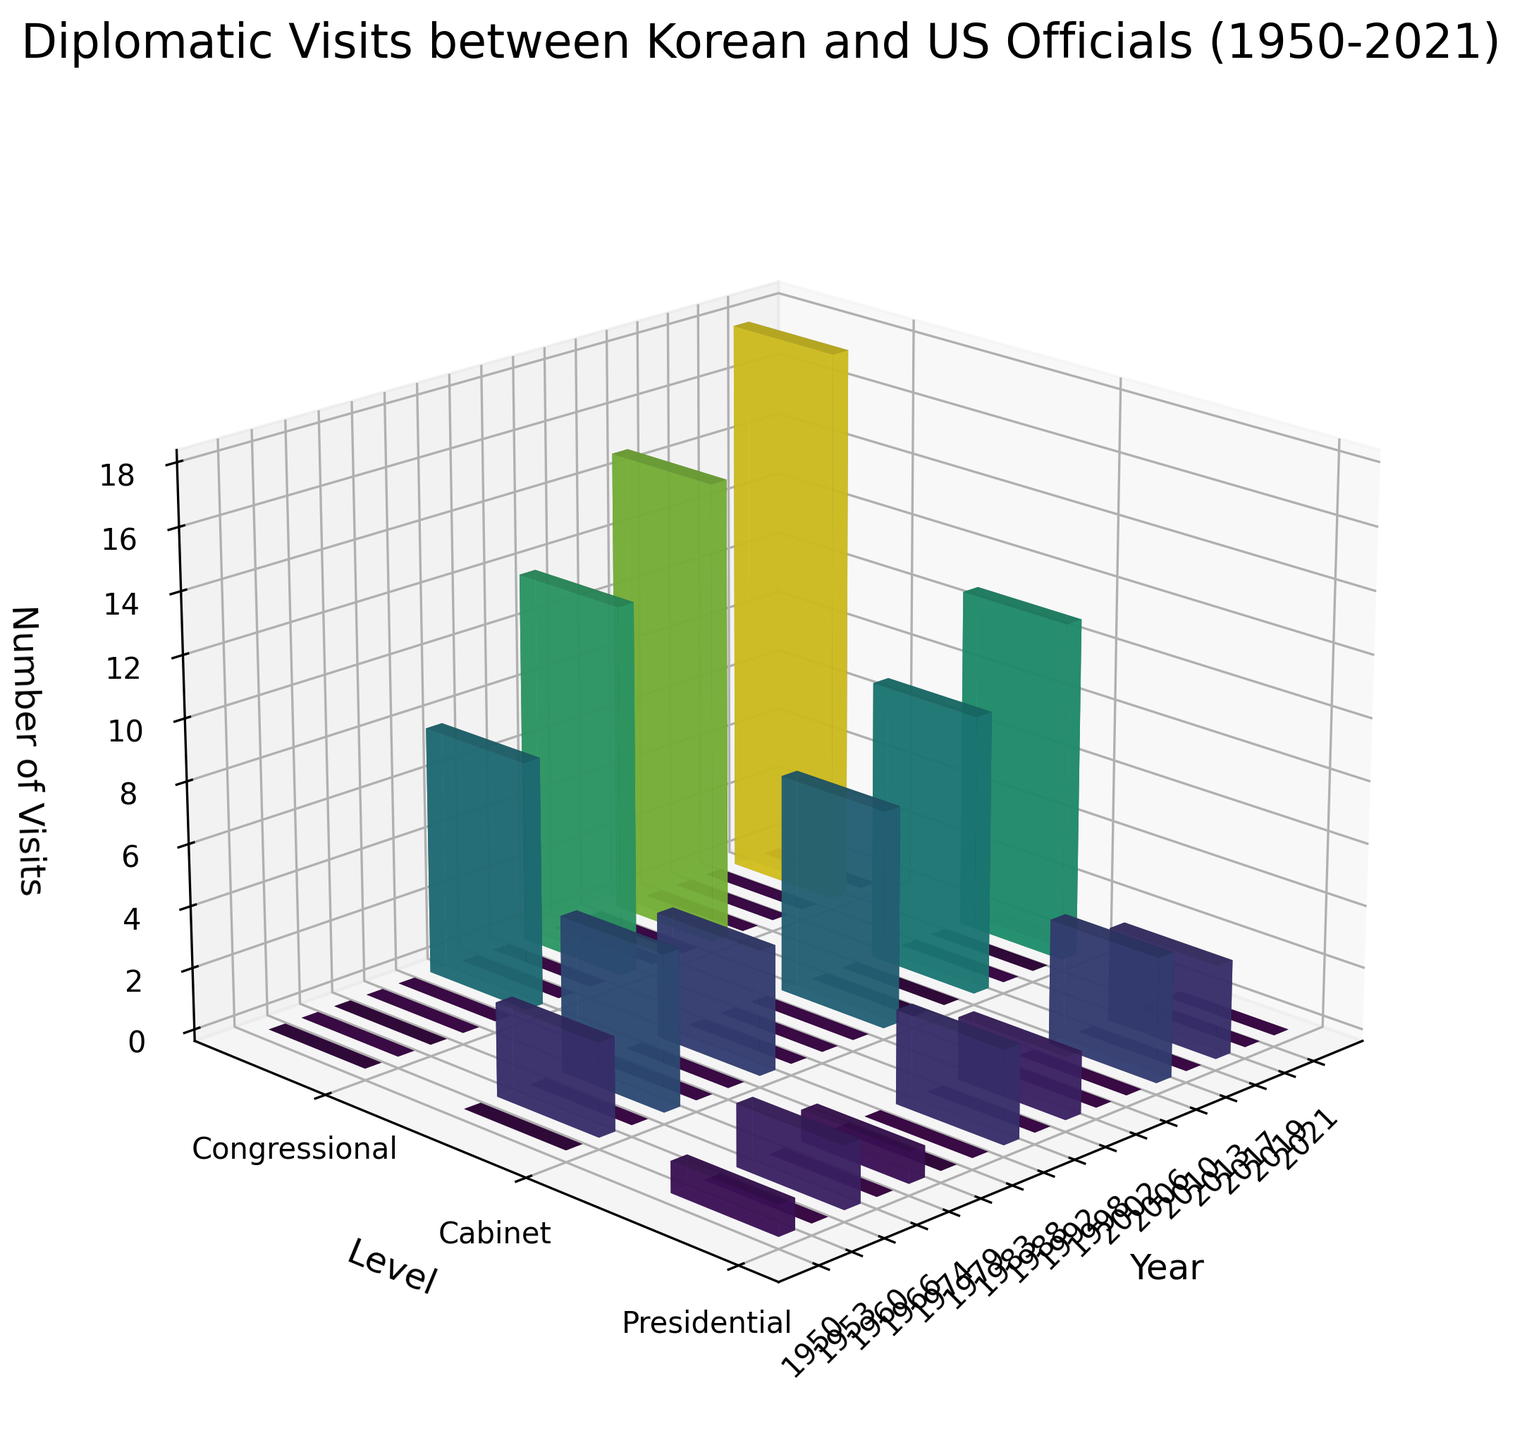What is the title of the plot? The title is the text located at the top of the plot which describes the overall content.
Answer: Diplomatic Visits between Korean and US Officials (1950-2021) What are the levels of government represented in the plot? The levels can be identified by looking at the y-axis labels in the plot.
Answer: Presidential, Cabinet, Congressional Which level of government had the highest number of visits in any given year? This requires scanning the bars in the plot to find the tallest one, then identifying its corresponding level. The highest bar is found in the Congressional level.
Answer: Congressional In which year did the Congressional level have the most visits? Observe the Congressional bars and identify the year associated with the tallest bar. The year corresponding to the highest bar is 2019.
Answer: 2019 How many presidential visits were recorded in 1988? Find the bar associated with the year 1988 and the level Presidential and note the height of the bar.
Answer: 3 What is the total number of visits recorded in the year 2013? Sum up the heights of all bars for the year 2013 at different levels. Cabinet: 9 visits. Adding them gives a total of 9 visits.
Answer: 9 Compare the number of visits at the Cabinet level in 2002 and 2013. Which year had more visits? Check the heights of the bars for the Cabinet level in 2002 and 2013. 2002 has 7 visits and 2013 has 9 visits. So, 2013 has more visits.
Answer: 2013 Identify the trend in the number of Congressional visits over the years shown in the figure. Review the heights of the Congressional bars at various years and describe the pattern. Congressional visits generally increase, with significant peaks.
Answer: Increasing trend Which years saw exactly 1 visit at the Presidential level? Look at the Presidential level and identify the years where the bar height is 1.
Answer: 1950, 1974 What is the average number of visits for the Presidential level across all years? Sum the heights of all the Presidential bars and divide by the number of years where visits are recorded. (1 + 2 + 1 + 3 + 2 + 4 + 3)/7 = 2.29 (rounded to 2 decimal places).
Answer: 2.29 